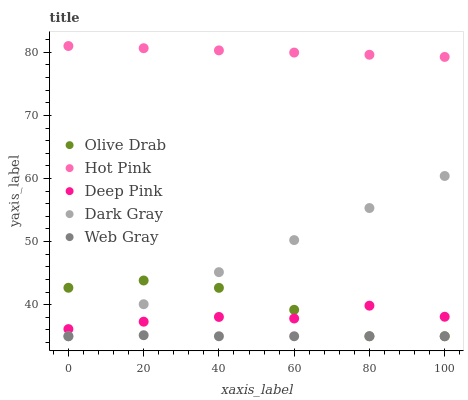Does Web Gray have the minimum area under the curve?
Answer yes or no. Yes. Does Hot Pink have the maximum area under the curve?
Answer yes or no. Yes. Does Hot Pink have the minimum area under the curve?
Answer yes or no. No. Does Web Gray have the maximum area under the curve?
Answer yes or no. No. Is Hot Pink the smoothest?
Answer yes or no. Yes. Is Olive Drab the roughest?
Answer yes or no. Yes. Is Web Gray the smoothest?
Answer yes or no. No. Is Web Gray the roughest?
Answer yes or no. No. Does Dark Gray have the lowest value?
Answer yes or no. Yes. Does Hot Pink have the lowest value?
Answer yes or no. No. Does Hot Pink have the highest value?
Answer yes or no. Yes. Does Web Gray have the highest value?
Answer yes or no. No. Is Deep Pink less than Hot Pink?
Answer yes or no. Yes. Is Deep Pink greater than Web Gray?
Answer yes or no. Yes. Does Dark Gray intersect Olive Drab?
Answer yes or no. Yes. Is Dark Gray less than Olive Drab?
Answer yes or no. No. Is Dark Gray greater than Olive Drab?
Answer yes or no. No. Does Deep Pink intersect Hot Pink?
Answer yes or no. No. 